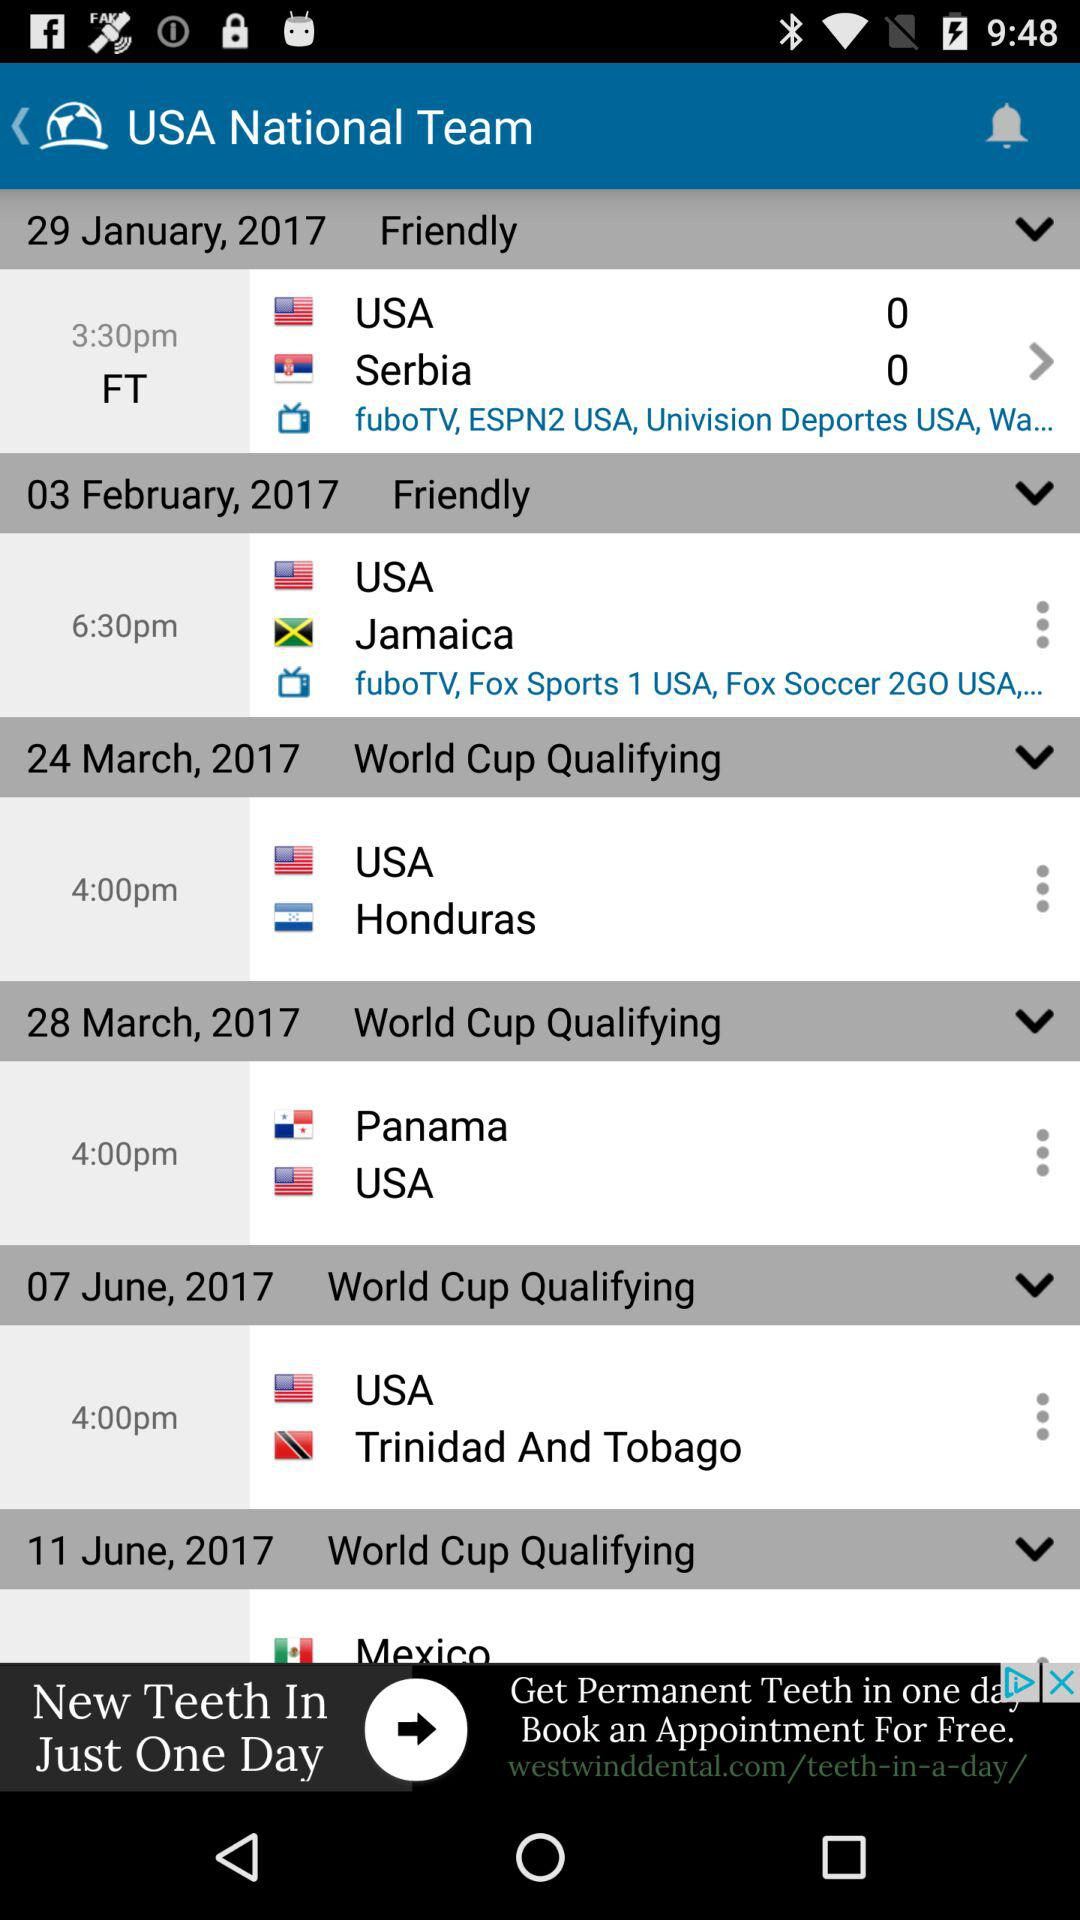On March 28, 2017, between which two teams will the match be held? The match will be held between "Panama" and "USA". 